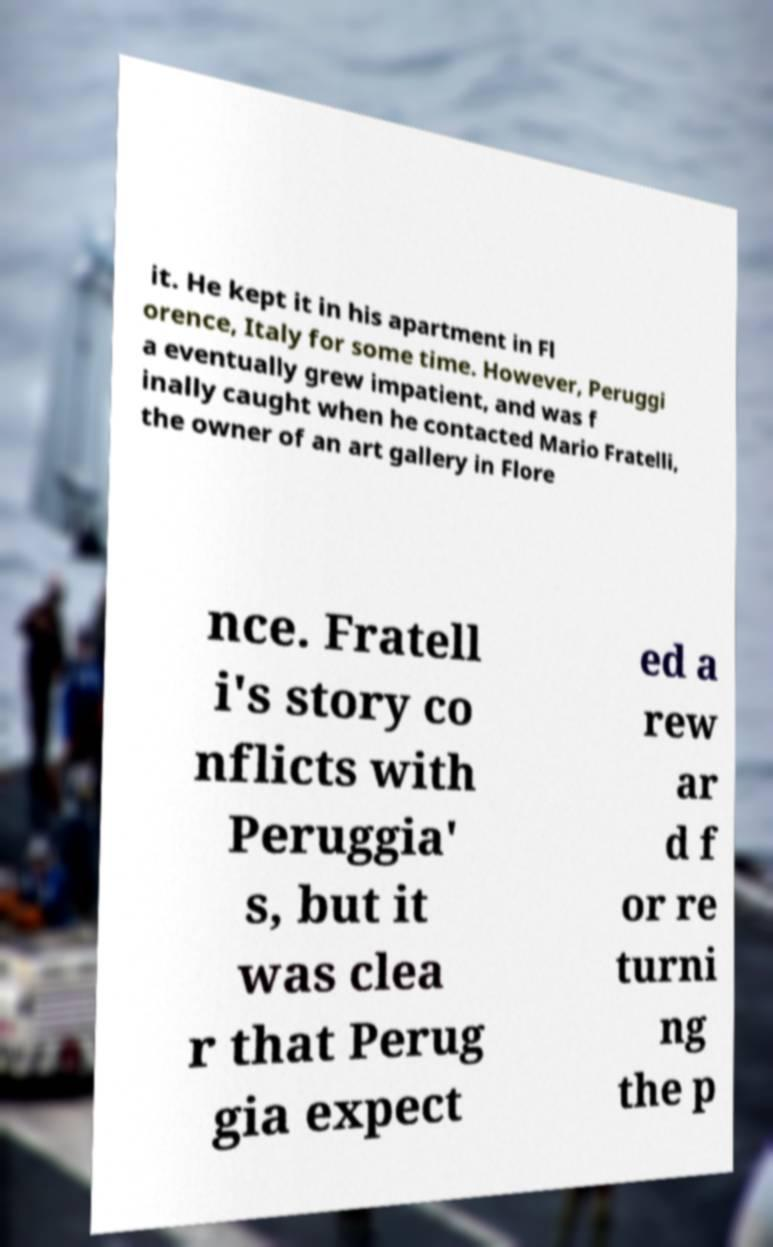Please identify and transcribe the text found in this image. it. He kept it in his apartment in Fl orence, Italy for some time. However, Peruggi a eventually grew impatient, and was f inally caught when he contacted Mario Fratelli, the owner of an art gallery in Flore nce. Fratell i's story co nflicts with Peruggia' s, but it was clea r that Perug gia expect ed a rew ar d f or re turni ng the p 